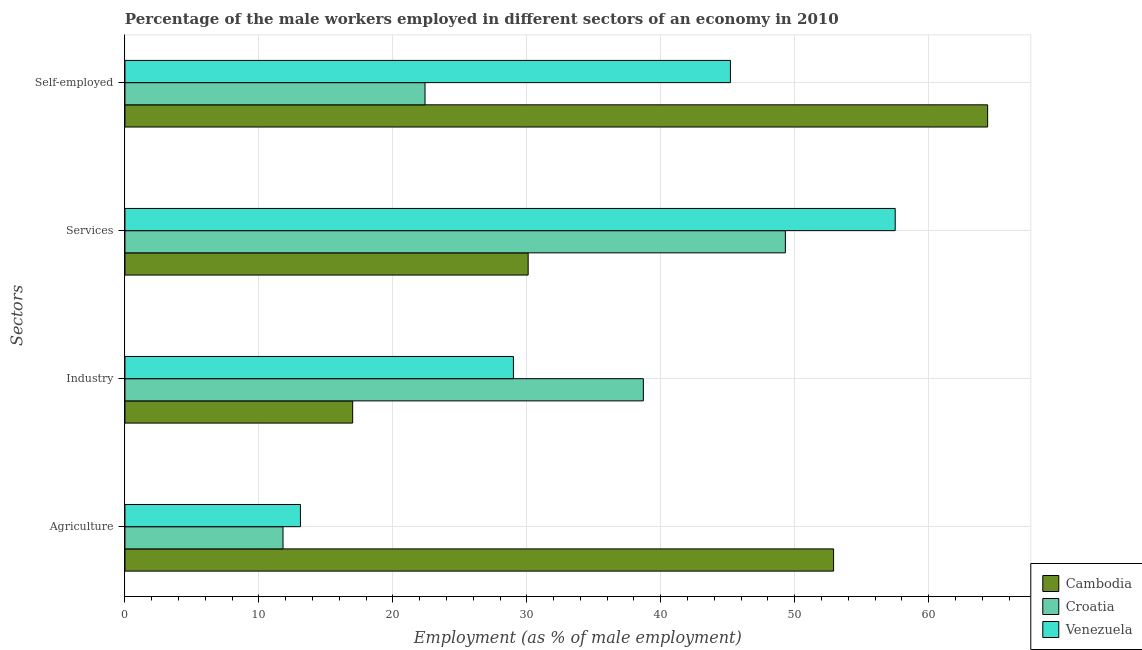Are the number of bars on each tick of the Y-axis equal?
Make the answer very short. Yes. How many bars are there on the 1st tick from the top?
Ensure brevity in your answer.  3. How many bars are there on the 2nd tick from the bottom?
Provide a succinct answer. 3. What is the label of the 4th group of bars from the top?
Your answer should be very brief. Agriculture. What is the percentage of male workers in industry in Venezuela?
Give a very brief answer. 29. Across all countries, what is the maximum percentage of male workers in industry?
Give a very brief answer. 38.7. Across all countries, what is the minimum percentage of male workers in services?
Your answer should be very brief. 30.1. In which country was the percentage of male workers in services maximum?
Your answer should be very brief. Venezuela. In which country was the percentage of self employed male workers minimum?
Provide a succinct answer. Croatia. What is the total percentage of male workers in industry in the graph?
Give a very brief answer. 84.7. What is the difference between the percentage of self employed male workers in Cambodia and that in Croatia?
Ensure brevity in your answer.  42. What is the difference between the percentage of male workers in agriculture in Croatia and the percentage of male workers in services in Cambodia?
Keep it short and to the point. -18.3. What is the average percentage of male workers in services per country?
Make the answer very short. 45.63. What is the difference between the percentage of self employed male workers and percentage of male workers in services in Venezuela?
Your answer should be compact. -12.3. What is the ratio of the percentage of self employed male workers in Croatia to that in Cambodia?
Make the answer very short. 0.35. Is the percentage of self employed male workers in Croatia less than that in Cambodia?
Give a very brief answer. Yes. What is the difference between the highest and the second highest percentage of self employed male workers?
Make the answer very short. 19.2. What is the difference between the highest and the lowest percentage of male workers in agriculture?
Offer a terse response. 41.1. Is the sum of the percentage of male workers in services in Venezuela and Cambodia greater than the maximum percentage of male workers in industry across all countries?
Provide a short and direct response. Yes. What does the 1st bar from the top in Agriculture represents?
Your answer should be compact. Venezuela. What does the 1st bar from the bottom in Self-employed represents?
Offer a very short reply. Cambodia. How many countries are there in the graph?
Offer a terse response. 3. Does the graph contain any zero values?
Provide a short and direct response. No. Does the graph contain grids?
Ensure brevity in your answer.  Yes. Where does the legend appear in the graph?
Give a very brief answer. Bottom right. How are the legend labels stacked?
Provide a short and direct response. Vertical. What is the title of the graph?
Keep it short and to the point. Percentage of the male workers employed in different sectors of an economy in 2010. Does "Dominican Republic" appear as one of the legend labels in the graph?
Ensure brevity in your answer.  No. What is the label or title of the X-axis?
Offer a terse response. Employment (as % of male employment). What is the label or title of the Y-axis?
Offer a very short reply. Sectors. What is the Employment (as % of male employment) in Cambodia in Agriculture?
Ensure brevity in your answer.  52.9. What is the Employment (as % of male employment) of Croatia in Agriculture?
Make the answer very short. 11.8. What is the Employment (as % of male employment) of Venezuela in Agriculture?
Ensure brevity in your answer.  13.1. What is the Employment (as % of male employment) in Cambodia in Industry?
Ensure brevity in your answer.  17. What is the Employment (as % of male employment) in Croatia in Industry?
Give a very brief answer. 38.7. What is the Employment (as % of male employment) in Venezuela in Industry?
Provide a succinct answer. 29. What is the Employment (as % of male employment) in Cambodia in Services?
Make the answer very short. 30.1. What is the Employment (as % of male employment) in Croatia in Services?
Make the answer very short. 49.3. What is the Employment (as % of male employment) in Venezuela in Services?
Offer a terse response. 57.5. What is the Employment (as % of male employment) in Cambodia in Self-employed?
Make the answer very short. 64.4. What is the Employment (as % of male employment) in Croatia in Self-employed?
Your answer should be compact. 22.4. What is the Employment (as % of male employment) in Venezuela in Self-employed?
Your response must be concise. 45.2. Across all Sectors, what is the maximum Employment (as % of male employment) in Cambodia?
Your response must be concise. 64.4. Across all Sectors, what is the maximum Employment (as % of male employment) of Croatia?
Make the answer very short. 49.3. Across all Sectors, what is the maximum Employment (as % of male employment) in Venezuela?
Ensure brevity in your answer.  57.5. Across all Sectors, what is the minimum Employment (as % of male employment) of Croatia?
Offer a terse response. 11.8. Across all Sectors, what is the minimum Employment (as % of male employment) of Venezuela?
Keep it short and to the point. 13.1. What is the total Employment (as % of male employment) of Cambodia in the graph?
Provide a short and direct response. 164.4. What is the total Employment (as % of male employment) in Croatia in the graph?
Give a very brief answer. 122.2. What is the total Employment (as % of male employment) in Venezuela in the graph?
Offer a terse response. 144.8. What is the difference between the Employment (as % of male employment) of Cambodia in Agriculture and that in Industry?
Your answer should be compact. 35.9. What is the difference between the Employment (as % of male employment) in Croatia in Agriculture and that in Industry?
Ensure brevity in your answer.  -26.9. What is the difference between the Employment (as % of male employment) of Venezuela in Agriculture and that in Industry?
Ensure brevity in your answer.  -15.9. What is the difference between the Employment (as % of male employment) in Cambodia in Agriculture and that in Services?
Your answer should be very brief. 22.8. What is the difference between the Employment (as % of male employment) of Croatia in Agriculture and that in Services?
Your answer should be very brief. -37.5. What is the difference between the Employment (as % of male employment) in Venezuela in Agriculture and that in Services?
Ensure brevity in your answer.  -44.4. What is the difference between the Employment (as % of male employment) in Cambodia in Agriculture and that in Self-employed?
Your response must be concise. -11.5. What is the difference between the Employment (as % of male employment) of Venezuela in Agriculture and that in Self-employed?
Ensure brevity in your answer.  -32.1. What is the difference between the Employment (as % of male employment) in Venezuela in Industry and that in Services?
Make the answer very short. -28.5. What is the difference between the Employment (as % of male employment) in Cambodia in Industry and that in Self-employed?
Offer a very short reply. -47.4. What is the difference between the Employment (as % of male employment) of Croatia in Industry and that in Self-employed?
Keep it short and to the point. 16.3. What is the difference between the Employment (as % of male employment) in Venezuela in Industry and that in Self-employed?
Your answer should be very brief. -16.2. What is the difference between the Employment (as % of male employment) of Cambodia in Services and that in Self-employed?
Your response must be concise. -34.3. What is the difference between the Employment (as % of male employment) of Croatia in Services and that in Self-employed?
Keep it short and to the point. 26.9. What is the difference between the Employment (as % of male employment) of Cambodia in Agriculture and the Employment (as % of male employment) of Venezuela in Industry?
Make the answer very short. 23.9. What is the difference between the Employment (as % of male employment) in Croatia in Agriculture and the Employment (as % of male employment) in Venezuela in Industry?
Make the answer very short. -17.2. What is the difference between the Employment (as % of male employment) of Croatia in Agriculture and the Employment (as % of male employment) of Venezuela in Services?
Ensure brevity in your answer.  -45.7. What is the difference between the Employment (as % of male employment) in Cambodia in Agriculture and the Employment (as % of male employment) in Croatia in Self-employed?
Provide a short and direct response. 30.5. What is the difference between the Employment (as % of male employment) in Croatia in Agriculture and the Employment (as % of male employment) in Venezuela in Self-employed?
Offer a very short reply. -33.4. What is the difference between the Employment (as % of male employment) of Cambodia in Industry and the Employment (as % of male employment) of Croatia in Services?
Ensure brevity in your answer.  -32.3. What is the difference between the Employment (as % of male employment) of Cambodia in Industry and the Employment (as % of male employment) of Venezuela in Services?
Your answer should be very brief. -40.5. What is the difference between the Employment (as % of male employment) of Croatia in Industry and the Employment (as % of male employment) of Venezuela in Services?
Your answer should be very brief. -18.8. What is the difference between the Employment (as % of male employment) of Cambodia in Industry and the Employment (as % of male employment) of Croatia in Self-employed?
Keep it short and to the point. -5.4. What is the difference between the Employment (as % of male employment) of Cambodia in Industry and the Employment (as % of male employment) of Venezuela in Self-employed?
Your response must be concise. -28.2. What is the difference between the Employment (as % of male employment) in Cambodia in Services and the Employment (as % of male employment) in Venezuela in Self-employed?
Provide a succinct answer. -15.1. What is the average Employment (as % of male employment) in Cambodia per Sectors?
Ensure brevity in your answer.  41.1. What is the average Employment (as % of male employment) in Croatia per Sectors?
Your answer should be very brief. 30.55. What is the average Employment (as % of male employment) of Venezuela per Sectors?
Provide a succinct answer. 36.2. What is the difference between the Employment (as % of male employment) in Cambodia and Employment (as % of male employment) in Croatia in Agriculture?
Keep it short and to the point. 41.1. What is the difference between the Employment (as % of male employment) of Cambodia and Employment (as % of male employment) of Venezuela in Agriculture?
Provide a succinct answer. 39.8. What is the difference between the Employment (as % of male employment) in Croatia and Employment (as % of male employment) in Venezuela in Agriculture?
Provide a succinct answer. -1.3. What is the difference between the Employment (as % of male employment) of Cambodia and Employment (as % of male employment) of Croatia in Industry?
Make the answer very short. -21.7. What is the difference between the Employment (as % of male employment) in Cambodia and Employment (as % of male employment) in Venezuela in Industry?
Provide a succinct answer. -12. What is the difference between the Employment (as % of male employment) of Cambodia and Employment (as % of male employment) of Croatia in Services?
Your response must be concise. -19.2. What is the difference between the Employment (as % of male employment) in Cambodia and Employment (as % of male employment) in Venezuela in Services?
Offer a very short reply. -27.4. What is the difference between the Employment (as % of male employment) in Cambodia and Employment (as % of male employment) in Croatia in Self-employed?
Provide a short and direct response. 42. What is the difference between the Employment (as % of male employment) in Croatia and Employment (as % of male employment) in Venezuela in Self-employed?
Your answer should be compact. -22.8. What is the ratio of the Employment (as % of male employment) of Cambodia in Agriculture to that in Industry?
Keep it short and to the point. 3.11. What is the ratio of the Employment (as % of male employment) in Croatia in Agriculture to that in Industry?
Make the answer very short. 0.3. What is the ratio of the Employment (as % of male employment) in Venezuela in Agriculture to that in Industry?
Offer a very short reply. 0.45. What is the ratio of the Employment (as % of male employment) in Cambodia in Agriculture to that in Services?
Provide a short and direct response. 1.76. What is the ratio of the Employment (as % of male employment) in Croatia in Agriculture to that in Services?
Offer a very short reply. 0.24. What is the ratio of the Employment (as % of male employment) of Venezuela in Agriculture to that in Services?
Your response must be concise. 0.23. What is the ratio of the Employment (as % of male employment) of Cambodia in Agriculture to that in Self-employed?
Your response must be concise. 0.82. What is the ratio of the Employment (as % of male employment) of Croatia in Agriculture to that in Self-employed?
Provide a short and direct response. 0.53. What is the ratio of the Employment (as % of male employment) in Venezuela in Agriculture to that in Self-employed?
Your response must be concise. 0.29. What is the ratio of the Employment (as % of male employment) of Cambodia in Industry to that in Services?
Keep it short and to the point. 0.56. What is the ratio of the Employment (as % of male employment) of Croatia in Industry to that in Services?
Make the answer very short. 0.79. What is the ratio of the Employment (as % of male employment) in Venezuela in Industry to that in Services?
Ensure brevity in your answer.  0.5. What is the ratio of the Employment (as % of male employment) in Cambodia in Industry to that in Self-employed?
Your response must be concise. 0.26. What is the ratio of the Employment (as % of male employment) of Croatia in Industry to that in Self-employed?
Your response must be concise. 1.73. What is the ratio of the Employment (as % of male employment) of Venezuela in Industry to that in Self-employed?
Your answer should be very brief. 0.64. What is the ratio of the Employment (as % of male employment) of Cambodia in Services to that in Self-employed?
Keep it short and to the point. 0.47. What is the ratio of the Employment (as % of male employment) in Croatia in Services to that in Self-employed?
Provide a succinct answer. 2.2. What is the ratio of the Employment (as % of male employment) in Venezuela in Services to that in Self-employed?
Offer a terse response. 1.27. What is the difference between the highest and the second highest Employment (as % of male employment) in Cambodia?
Provide a short and direct response. 11.5. What is the difference between the highest and the second highest Employment (as % of male employment) in Croatia?
Make the answer very short. 10.6. What is the difference between the highest and the lowest Employment (as % of male employment) of Cambodia?
Your response must be concise. 47.4. What is the difference between the highest and the lowest Employment (as % of male employment) of Croatia?
Your answer should be compact. 37.5. What is the difference between the highest and the lowest Employment (as % of male employment) in Venezuela?
Make the answer very short. 44.4. 